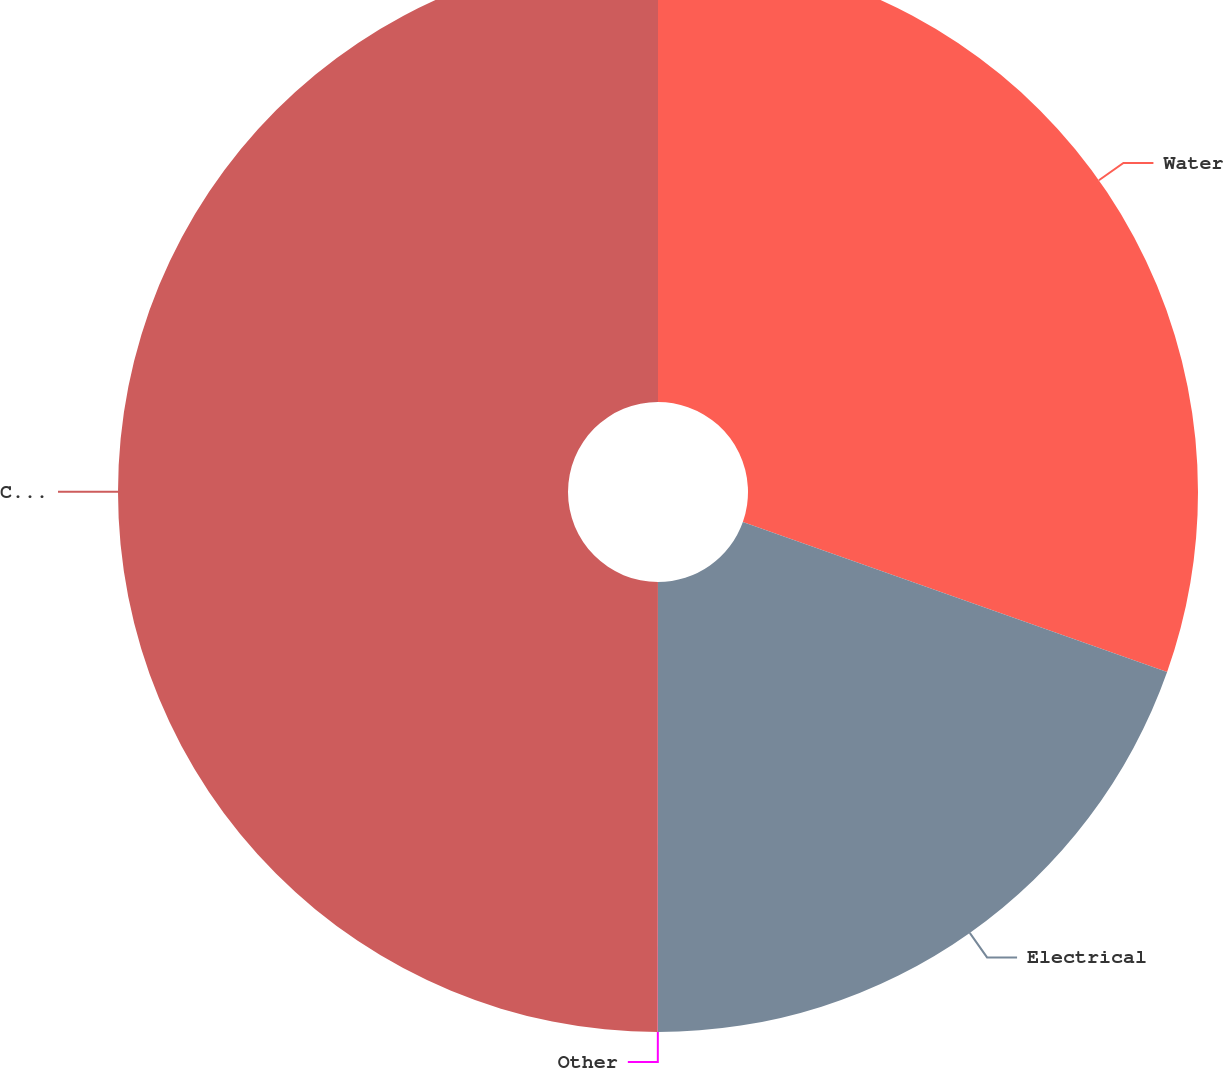Convert chart. <chart><loc_0><loc_0><loc_500><loc_500><pie_chart><fcel>Water<fcel>Electrical<fcel>Other<fcel>Consolidated<nl><fcel>30.41%<fcel>19.59%<fcel>0.01%<fcel>49.99%<nl></chart> 